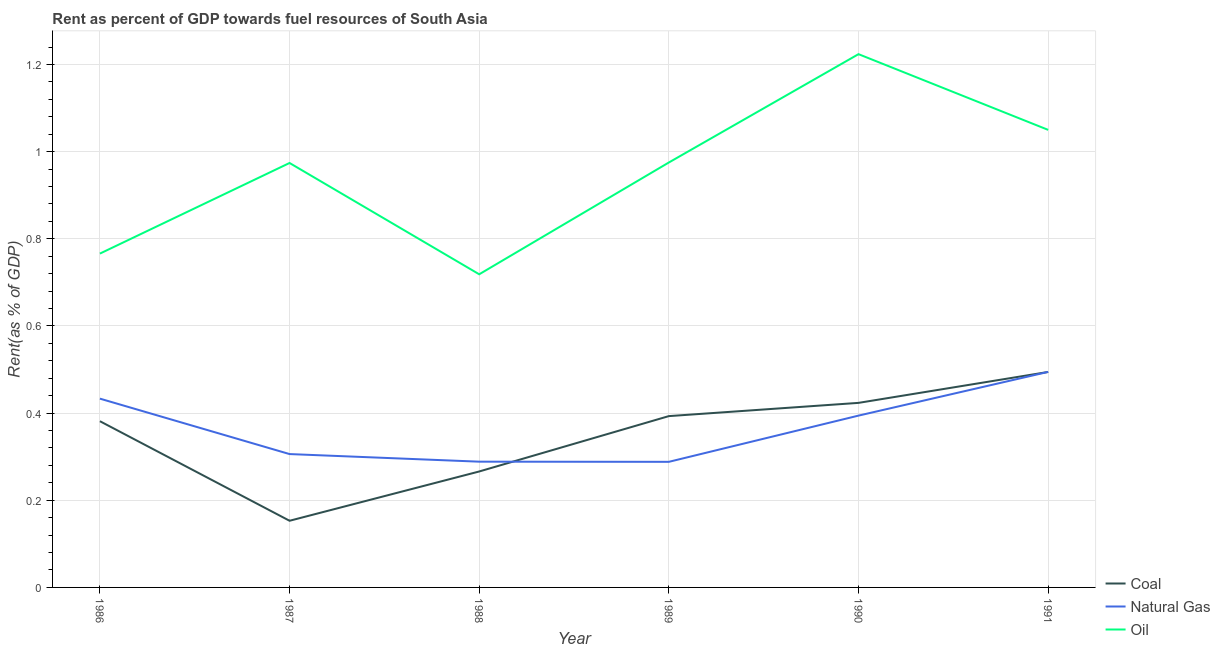Does the line corresponding to rent towards coal intersect with the line corresponding to rent towards oil?
Ensure brevity in your answer.  No. What is the rent towards natural gas in 1991?
Offer a very short reply. 0.49. Across all years, what is the maximum rent towards natural gas?
Provide a succinct answer. 0.49. Across all years, what is the minimum rent towards coal?
Your response must be concise. 0.15. In which year was the rent towards coal maximum?
Offer a very short reply. 1991. In which year was the rent towards oil minimum?
Give a very brief answer. 1988. What is the total rent towards oil in the graph?
Keep it short and to the point. 5.71. What is the difference between the rent towards natural gas in 1986 and that in 1987?
Your answer should be compact. 0.13. What is the difference between the rent towards coal in 1986 and the rent towards oil in 1990?
Give a very brief answer. -0.84. What is the average rent towards natural gas per year?
Your answer should be compact. 0.37. In the year 1989, what is the difference between the rent towards natural gas and rent towards coal?
Provide a short and direct response. -0.1. What is the ratio of the rent towards coal in 1987 to that in 1990?
Your response must be concise. 0.36. Is the difference between the rent towards natural gas in 1986 and 1989 greater than the difference between the rent towards oil in 1986 and 1989?
Your answer should be compact. Yes. What is the difference between the highest and the second highest rent towards natural gas?
Ensure brevity in your answer.  0.06. What is the difference between the highest and the lowest rent towards oil?
Offer a terse response. 0.51. Does the rent towards oil monotonically increase over the years?
Your answer should be very brief. No. Is the rent towards coal strictly less than the rent towards oil over the years?
Provide a short and direct response. Yes. How many lines are there?
Your response must be concise. 3. What is the difference between two consecutive major ticks on the Y-axis?
Offer a terse response. 0.2. How many legend labels are there?
Make the answer very short. 3. How are the legend labels stacked?
Give a very brief answer. Vertical. What is the title of the graph?
Provide a short and direct response. Rent as percent of GDP towards fuel resources of South Asia. What is the label or title of the X-axis?
Keep it short and to the point. Year. What is the label or title of the Y-axis?
Keep it short and to the point. Rent(as % of GDP). What is the Rent(as % of GDP) in Coal in 1986?
Provide a succinct answer. 0.38. What is the Rent(as % of GDP) of Natural Gas in 1986?
Your answer should be very brief. 0.43. What is the Rent(as % of GDP) of Oil in 1986?
Your response must be concise. 0.77. What is the Rent(as % of GDP) in Coal in 1987?
Offer a very short reply. 0.15. What is the Rent(as % of GDP) of Natural Gas in 1987?
Provide a short and direct response. 0.31. What is the Rent(as % of GDP) in Oil in 1987?
Give a very brief answer. 0.97. What is the Rent(as % of GDP) of Coal in 1988?
Offer a very short reply. 0.27. What is the Rent(as % of GDP) of Natural Gas in 1988?
Make the answer very short. 0.29. What is the Rent(as % of GDP) of Oil in 1988?
Ensure brevity in your answer.  0.72. What is the Rent(as % of GDP) in Coal in 1989?
Offer a very short reply. 0.39. What is the Rent(as % of GDP) in Natural Gas in 1989?
Ensure brevity in your answer.  0.29. What is the Rent(as % of GDP) of Oil in 1989?
Ensure brevity in your answer.  0.98. What is the Rent(as % of GDP) of Coal in 1990?
Make the answer very short. 0.42. What is the Rent(as % of GDP) in Natural Gas in 1990?
Your answer should be very brief. 0.39. What is the Rent(as % of GDP) in Oil in 1990?
Ensure brevity in your answer.  1.22. What is the Rent(as % of GDP) in Coal in 1991?
Offer a very short reply. 0.49. What is the Rent(as % of GDP) in Natural Gas in 1991?
Your answer should be very brief. 0.49. What is the Rent(as % of GDP) in Oil in 1991?
Your response must be concise. 1.05. Across all years, what is the maximum Rent(as % of GDP) in Coal?
Your answer should be compact. 0.49. Across all years, what is the maximum Rent(as % of GDP) of Natural Gas?
Your answer should be very brief. 0.49. Across all years, what is the maximum Rent(as % of GDP) in Oil?
Give a very brief answer. 1.22. Across all years, what is the minimum Rent(as % of GDP) in Coal?
Offer a very short reply. 0.15. Across all years, what is the minimum Rent(as % of GDP) of Natural Gas?
Give a very brief answer. 0.29. Across all years, what is the minimum Rent(as % of GDP) in Oil?
Keep it short and to the point. 0.72. What is the total Rent(as % of GDP) of Coal in the graph?
Ensure brevity in your answer.  2.11. What is the total Rent(as % of GDP) in Natural Gas in the graph?
Your response must be concise. 2.21. What is the total Rent(as % of GDP) of Oil in the graph?
Make the answer very short. 5.71. What is the difference between the Rent(as % of GDP) of Coal in 1986 and that in 1987?
Your answer should be very brief. 0.23. What is the difference between the Rent(as % of GDP) in Natural Gas in 1986 and that in 1987?
Offer a very short reply. 0.13. What is the difference between the Rent(as % of GDP) in Oil in 1986 and that in 1987?
Keep it short and to the point. -0.21. What is the difference between the Rent(as % of GDP) in Coal in 1986 and that in 1988?
Ensure brevity in your answer.  0.12. What is the difference between the Rent(as % of GDP) of Natural Gas in 1986 and that in 1988?
Provide a short and direct response. 0.14. What is the difference between the Rent(as % of GDP) in Oil in 1986 and that in 1988?
Provide a short and direct response. 0.05. What is the difference between the Rent(as % of GDP) of Coal in 1986 and that in 1989?
Your response must be concise. -0.01. What is the difference between the Rent(as % of GDP) in Natural Gas in 1986 and that in 1989?
Offer a very short reply. 0.15. What is the difference between the Rent(as % of GDP) of Oil in 1986 and that in 1989?
Offer a very short reply. -0.21. What is the difference between the Rent(as % of GDP) of Coal in 1986 and that in 1990?
Provide a succinct answer. -0.04. What is the difference between the Rent(as % of GDP) in Natural Gas in 1986 and that in 1990?
Offer a very short reply. 0.04. What is the difference between the Rent(as % of GDP) of Oil in 1986 and that in 1990?
Your answer should be compact. -0.46. What is the difference between the Rent(as % of GDP) of Coal in 1986 and that in 1991?
Provide a succinct answer. -0.11. What is the difference between the Rent(as % of GDP) of Natural Gas in 1986 and that in 1991?
Offer a very short reply. -0.06. What is the difference between the Rent(as % of GDP) of Oil in 1986 and that in 1991?
Your answer should be compact. -0.28. What is the difference between the Rent(as % of GDP) of Coal in 1987 and that in 1988?
Your answer should be very brief. -0.11. What is the difference between the Rent(as % of GDP) of Natural Gas in 1987 and that in 1988?
Give a very brief answer. 0.02. What is the difference between the Rent(as % of GDP) in Oil in 1987 and that in 1988?
Provide a succinct answer. 0.26. What is the difference between the Rent(as % of GDP) of Coal in 1987 and that in 1989?
Ensure brevity in your answer.  -0.24. What is the difference between the Rent(as % of GDP) in Natural Gas in 1987 and that in 1989?
Your response must be concise. 0.02. What is the difference between the Rent(as % of GDP) in Oil in 1987 and that in 1989?
Make the answer very short. -0. What is the difference between the Rent(as % of GDP) in Coal in 1987 and that in 1990?
Keep it short and to the point. -0.27. What is the difference between the Rent(as % of GDP) in Natural Gas in 1987 and that in 1990?
Keep it short and to the point. -0.09. What is the difference between the Rent(as % of GDP) in Oil in 1987 and that in 1990?
Provide a succinct answer. -0.25. What is the difference between the Rent(as % of GDP) in Coal in 1987 and that in 1991?
Your answer should be very brief. -0.34. What is the difference between the Rent(as % of GDP) in Natural Gas in 1987 and that in 1991?
Provide a succinct answer. -0.19. What is the difference between the Rent(as % of GDP) of Oil in 1987 and that in 1991?
Your answer should be very brief. -0.08. What is the difference between the Rent(as % of GDP) of Coal in 1988 and that in 1989?
Offer a terse response. -0.13. What is the difference between the Rent(as % of GDP) in Natural Gas in 1988 and that in 1989?
Provide a short and direct response. 0. What is the difference between the Rent(as % of GDP) in Oil in 1988 and that in 1989?
Provide a short and direct response. -0.26. What is the difference between the Rent(as % of GDP) in Coal in 1988 and that in 1990?
Offer a terse response. -0.16. What is the difference between the Rent(as % of GDP) in Natural Gas in 1988 and that in 1990?
Offer a very short reply. -0.11. What is the difference between the Rent(as % of GDP) of Oil in 1988 and that in 1990?
Give a very brief answer. -0.51. What is the difference between the Rent(as % of GDP) in Coal in 1988 and that in 1991?
Keep it short and to the point. -0.23. What is the difference between the Rent(as % of GDP) of Natural Gas in 1988 and that in 1991?
Offer a terse response. -0.21. What is the difference between the Rent(as % of GDP) of Oil in 1988 and that in 1991?
Offer a very short reply. -0.33. What is the difference between the Rent(as % of GDP) in Coal in 1989 and that in 1990?
Your answer should be compact. -0.03. What is the difference between the Rent(as % of GDP) of Natural Gas in 1989 and that in 1990?
Make the answer very short. -0.11. What is the difference between the Rent(as % of GDP) of Oil in 1989 and that in 1990?
Provide a succinct answer. -0.25. What is the difference between the Rent(as % of GDP) of Coal in 1989 and that in 1991?
Provide a short and direct response. -0.1. What is the difference between the Rent(as % of GDP) in Natural Gas in 1989 and that in 1991?
Provide a succinct answer. -0.21. What is the difference between the Rent(as % of GDP) in Oil in 1989 and that in 1991?
Give a very brief answer. -0.07. What is the difference between the Rent(as % of GDP) of Coal in 1990 and that in 1991?
Keep it short and to the point. -0.07. What is the difference between the Rent(as % of GDP) in Natural Gas in 1990 and that in 1991?
Keep it short and to the point. -0.1. What is the difference between the Rent(as % of GDP) of Oil in 1990 and that in 1991?
Your answer should be compact. 0.17. What is the difference between the Rent(as % of GDP) of Coal in 1986 and the Rent(as % of GDP) of Natural Gas in 1987?
Offer a very short reply. 0.08. What is the difference between the Rent(as % of GDP) of Coal in 1986 and the Rent(as % of GDP) of Oil in 1987?
Provide a short and direct response. -0.59. What is the difference between the Rent(as % of GDP) of Natural Gas in 1986 and the Rent(as % of GDP) of Oil in 1987?
Provide a succinct answer. -0.54. What is the difference between the Rent(as % of GDP) of Coal in 1986 and the Rent(as % of GDP) of Natural Gas in 1988?
Offer a terse response. 0.09. What is the difference between the Rent(as % of GDP) in Coal in 1986 and the Rent(as % of GDP) in Oil in 1988?
Ensure brevity in your answer.  -0.34. What is the difference between the Rent(as % of GDP) in Natural Gas in 1986 and the Rent(as % of GDP) in Oil in 1988?
Offer a terse response. -0.29. What is the difference between the Rent(as % of GDP) in Coal in 1986 and the Rent(as % of GDP) in Natural Gas in 1989?
Provide a succinct answer. 0.09. What is the difference between the Rent(as % of GDP) in Coal in 1986 and the Rent(as % of GDP) in Oil in 1989?
Give a very brief answer. -0.59. What is the difference between the Rent(as % of GDP) in Natural Gas in 1986 and the Rent(as % of GDP) in Oil in 1989?
Your answer should be compact. -0.54. What is the difference between the Rent(as % of GDP) of Coal in 1986 and the Rent(as % of GDP) of Natural Gas in 1990?
Your response must be concise. -0.01. What is the difference between the Rent(as % of GDP) of Coal in 1986 and the Rent(as % of GDP) of Oil in 1990?
Your answer should be compact. -0.84. What is the difference between the Rent(as % of GDP) in Natural Gas in 1986 and the Rent(as % of GDP) in Oil in 1990?
Ensure brevity in your answer.  -0.79. What is the difference between the Rent(as % of GDP) in Coal in 1986 and the Rent(as % of GDP) in Natural Gas in 1991?
Your answer should be compact. -0.11. What is the difference between the Rent(as % of GDP) of Coal in 1986 and the Rent(as % of GDP) of Oil in 1991?
Make the answer very short. -0.67. What is the difference between the Rent(as % of GDP) of Natural Gas in 1986 and the Rent(as % of GDP) of Oil in 1991?
Ensure brevity in your answer.  -0.62. What is the difference between the Rent(as % of GDP) in Coal in 1987 and the Rent(as % of GDP) in Natural Gas in 1988?
Provide a succinct answer. -0.14. What is the difference between the Rent(as % of GDP) of Coal in 1987 and the Rent(as % of GDP) of Oil in 1988?
Your response must be concise. -0.57. What is the difference between the Rent(as % of GDP) of Natural Gas in 1987 and the Rent(as % of GDP) of Oil in 1988?
Provide a succinct answer. -0.41. What is the difference between the Rent(as % of GDP) of Coal in 1987 and the Rent(as % of GDP) of Natural Gas in 1989?
Give a very brief answer. -0.14. What is the difference between the Rent(as % of GDP) in Coal in 1987 and the Rent(as % of GDP) in Oil in 1989?
Your answer should be very brief. -0.82. What is the difference between the Rent(as % of GDP) of Natural Gas in 1987 and the Rent(as % of GDP) of Oil in 1989?
Offer a terse response. -0.67. What is the difference between the Rent(as % of GDP) in Coal in 1987 and the Rent(as % of GDP) in Natural Gas in 1990?
Your answer should be very brief. -0.24. What is the difference between the Rent(as % of GDP) of Coal in 1987 and the Rent(as % of GDP) of Oil in 1990?
Your answer should be very brief. -1.07. What is the difference between the Rent(as % of GDP) in Natural Gas in 1987 and the Rent(as % of GDP) in Oil in 1990?
Ensure brevity in your answer.  -0.92. What is the difference between the Rent(as % of GDP) of Coal in 1987 and the Rent(as % of GDP) of Natural Gas in 1991?
Provide a short and direct response. -0.34. What is the difference between the Rent(as % of GDP) in Coal in 1987 and the Rent(as % of GDP) in Oil in 1991?
Provide a short and direct response. -0.9. What is the difference between the Rent(as % of GDP) of Natural Gas in 1987 and the Rent(as % of GDP) of Oil in 1991?
Keep it short and to the point. -0.74. What is the difference between the Rent(as % of GDP) in Coal in 1988 and the Rent(as % of GDP) in Natural Gas in 1989?
Provide a short and direct response. -0.02. What is the difference between the Rent(as % of GDP) in Coal in 1988 and the Rent(as % of GDP) in Oil in 1989?
Provide a succinct answer. -0.71. What is the difference between the Rent(as % of GDP) in Natural Gas in 1988 and the Rent(as % of GDP) in Oil in 1989?
Offer a terse response. -0.69. What is the difference between the Rent(as % of GDP) in Coal in 1988 and the Rent(as % of GDP) in Natural Gas in 1990?
Make the answer very short. -0.13. What is the difference between the Rent(as % of GDP) of Coal in 1988 and the Rent(as % of GDP) of Oil in 1990?
Provide a succinct answer. -0.96. What is the difference between the Rent(as % of GDP) of Natural Gas in 1988 and the Rent(as % of GDP) of Oil in 1990?
Ensure brevity in your answer.  -0.94. What is the difference between the Rent(as % of GDP) in Coal in 1988 and the Rent(as % of GDP) in Natural Gas in 1991?
Offer a very short reply. -0.23. What is the difference between the Rent(as % of GDP) of Coal in 1988 and the Rent(as % of GDP) of Oil in 1991?
Keep it short and to the point. -0.78. What is the difference between the Rent(as % of GDP) in Natural Gas in 1988 and the Rent(as % of GDP) in Oil in 1991?
Ensure brevity in your answer.  -0.76. What is the difference between the Rent(as % of GDP) of Coal in 1989 and the Rent(as % of GDP) of Natural Gas in 1990?
Provide a short and direct response. -0. What is the difference between the Rent(as % of GDP) of Coal in 1989 and the Rent(as % of GDP) of Oil in 1990?
Ensure brevity in your answer.  -0.83. What is the difference between the Rent(as % of GDP) in Natural Gas in 1989 and the Rent(as % of GDP) in Oil in 1990?
Provide a succinct answer. -0.94. What is the difference between the Rent(as % of GDP) of Coal in 1989 and the Rent(as % of GDP) of Natural Gas in 1991?
Offer a terse response. -0.1. What is the difference between the Rent(as % of GDP) of Coal in 1989 and the Rent(as % of GDP) of Oil in 1991?
Provide a succinct answer. -0.66. What is the difference between the Rent(as % of GDP) of Natural Gas in 1989 and the Rent(as % of GDP) of Oil in 1991?
Provide a short and direct response. -0.76. What is the difference between the Rent(as % of GDP) of Coal in 1990 and the Rent(as % of GDP) of Natural Gas in 1991?
Your answer should be compact. -0.07. What is the difference between the Rent(as % of GDP) in Coal in 1990 and the Rent(as % of GDP) in Oil in 1991?
Your answer should be very brief. -0.63. What is the difference between the Rent(as % of GDP) in Natural Gas in 1990 and the Rent(as % of GDP) in Oil in 1991?
Provide a short and direct response. -0.66. What is the average Rent(as % of GDP) in Coal per year?
Keep it short and to the point. 0.35. What is the average Rent(as % of GDP) in Natural Gas per year?
Ensure brevity in your answer.  0.37. What is the average Rent(as % of GDP) in Oil per year?
Keep it short and to the point. 0.95. In the year 1986, what is the difference between the Rent(as % of GDP) in Coal and Rent(as % of GDP) in Natural Gas?
Offer a terse response. -0.05. In the year 1986, what is the difference between the Rent(as % of GDP) of Coal and Rent(as % of GDP) of Oil?
Your answer should be very brief. -0.38. In the year 1986, what is the difference between the Rent(as % of GDP) of Natural Gas and Rent(as % of GDP) of Oil?
Your response must be concise. -0.33. In the year 1987, what is the difference between the Rent(as % of GDP) in Coal and Rent(as % of GDP) in Natural Gas?
Your answer should be very brief. -0.15. In the year 1987, what is the difference between the Rent(as % of GDP) in Coal and Rent(as % of GDP) in Oil?
Make the answer very short. -0.82. In the year 1987, what is the difference between the Rent(as % of GDP) in Natural Gas and Rent(as % of GDP) in Oil?
Offer a very short reply. -0.67. In the year 1988, what is the difference between the Rent(as % of GDP) in Coal and Rent(as % of GDP) in Natural Gas?
Provide a short and direct response. -0.02. In the year 1988, what is the difference between the Rent(as % of GDP) in Coal and Rent(as % of GDP) in Oil?
Your answer should be very brief. -0.45. In the year 1988, what is the difference between the Rent(as % of GDP) of Natural Gas and Rent(as % of GDP) of Oil?
Make the answer very short. -0.43. In the year 1989, what is the difference between the Rent(as % of GDP) of Coal and Rent(as % of GDP) of Natural Gas?
Give a very brief answer. 0.1. In the year 1989, what is the difference between the Rent(as % of GDP) of Coal and Rent(as % of GDP) of Oil?
Offer a very short reply. -0.58. In the year 1989, what is the difference between the Rent(as % of GDP) of Natural Gas and Rent(as % of GDP) of Oil?
Provide a short and direct response. -0.69. In the year 1990, what is the difference between the Rent(as % of GDP) in Coal and Rent(as % of GDP) in Natural Gas?
Offer a terse response. 0.03. In the year 1990, what is the difference between the Rent(as % of GDP) of Coal and Rent(as % of GDP) of Oil?
Offer a terse response. -0.8. In the year 1990, what is the difference between the Rent(as % of GDP) in Natural Gas and Rent(as % of GDP) in Oil?
Provide a short and direct response. -0.83. In the year 1991, what is the difference between the Rent(as % of GDP) of Coal and Rent(as % of GDP) of Natural Gas?
Ensure brevity in your answer.  -0. In the year 1991, what is the difference between the Rent(as % of GDP) in Coal and Rent(as % of GDP) in Oil?
Offer a very short reply. -0.56. In the year 1991, what is the difference between the Rent(as % of GDP) in Natural Gas and Rent(as % of GDP) in Oil?
Your answer should be compact. -0.56. What is the ratio of the Rent(as % of GDP) in Coal in 1986 to that in 1987?
Make the answer very short. 2.49. What is the ratio of the Rent(as % of GDP) in Natural Gas in 1986 to that in 1987?
Offer a very short reply. 1.42. What is the ratio of the Rent(as % of GDP) of Oil in 1986 to that in 1987?
Offer a terse response. 0.79. What is the ratio of the Rent(as % of GDP) in Coal in 1986 to that in 1988?
Make the answer very short. 1.43. What is the ratio of the Rent(as % of GDP) in Natural Gas in 1986 to that in 1988?
Give a very brief answer. 1.5. What is the ratio of the Rent(as % of GDP) of Oil in 1986 to that in 1988?
Your answer should be compact. 1.07. What is the ratio of the Rent(as % of GDP) of Coal in 1986 to that in 1989?
Your answer should be compact. 0.97. What is the ratio of the Rent(as % of GDP) in Natural Gas in 1986 to that in 1989?
Give a very brief answer. 1.5. What is the ratio of the Rent(as % of GDP) of Oil in 1986 to that in 1989?
Ensure brevity in your answer.  0.79. What is the ratio of the Rent(as % of GDP) of Coal in 1986 to that in 1990?
Make the answer very short. 0.9. What is the ratio of the Rent(as % of GDP) in Natural Gas in 1986 to that in 1990?
Ensure brevity in your answer.  1.1. What is the ratio of the Rent(as % of GDP) of Oil in 1986 to that in 1990?
Give a very brief answer. 0.63. What is the ratio of the Rent(as % of GDP) of Coal in 1986 to that in 1991?
Provide a succinct answer. 0.77. What is the ratio of the Rent(as % of GDP) of Natural Gas in 1986 to that in 1991?
Provide a succinct answer. 0.88. What is the ratio of the Rent(as % of GDP) in Oil in 1986 to that in 1991?
Offer a very short reply. 0.73. What is the ratio of the Rent(as % of GDP) of Coal in 1987 to that in 1988?
Provide a succinct answer. 0.57. What is the ratio of the Rent(as % of GDP) in Natural Gas in 1987 to that in 1988?
Offer a very short reply. 1.06. What is the ratio of the Rent(as % of GDP) of Oil in 1987 to that in 1988?
Ensure brevity in your answer.  1.36. What is the ratio of the Rent(as % of GDP) of Coal in 1987 to that in 1989?
Give a very brief answer. 0.39. What is the ratio of the Rent(as % of GDP) of Natural Gas in 1987 to that in 1989?
Provide a short and direct response. 1.06. What is the ratio of the Rent(as % of GDP) of Coal in 1987 to that in 1990?
Your answer should be compact. 0.36. What is the ratio of the Rent(as % of GDP) of Natural Gas in 1987 to that in 1990?
Keep it short and to the point. 0.78. What is the ratio of the Rent(as % of GDP) of Oil in 1987 to that in 1990?
Offer a terse response. 0.8. What is the ratio of the Rent(as % of GDP) of Coal in 1987 to that in 1991?
Offer a terse response. 0.31. What is the ratio of the Rent(as % of GDP) in Natural Gas in 1987 to that in 1991?
Provide a succinct answer. 0.62. What is the ratio of the Rent(as % of GDP) in Oil in 1987 to that in 1991?
Give a very brief answer. 0.93. What is the ratio of the Rent(as % of GDP) of Coal in 1988 to that in 1989?
Ensure brevity in your answer.  0.68. What is the ratio of the Rent(as % of GDP) in Natural Gas in 1988 to that in 1989?
Your answer should be very brief. 1. What is the ratio of the Rent(as % of GDP) of Oil in 1988 to that in 1989?
Make the answer very short. 0.74. What is the ratio of the Rent(as % of GDP) in Coal in 1988 to that in 1990?
Make the answer very short. 0.63. What is the ratio of the Rent(as % of GDP) of Natural Gas in 1988 to that in 1990?
Make the answer very short. 0.73. What is the ratio of the Rent(as % of GDP) of Oil in 1988 to that in 1990?
Your answer should be compact. 0.59. What is the ratio of the Rent(as % of GDP) of Coal in 1988 to that in 1991?
Keep it short and to the point. 0.54. What is the ratio of the Rent(as % of GDP) in Natural Gas in 1988 to that in 1991?
Your answer should be very brief. 0.58. What is the ratio of the Rent(as % of GDP) of Oil in 1988 to that in 1991?
Your response must be concise. 0.68. What is the ratio of the Rent(as % of GDP) in Coal in 1989 to that in 1990?
Make the answer very short. 0.93. What is the ratio of the Rent(as % of GDP) in Natural Gas in 1989 to that in 1990?
Offer a very short reply. 0.73. What is the ratio of the Rent(as % of GDP) in Oil in 1989 to that in 1990?
Give a very brief answer. 0.8. What is the ratio of the Rent(as % of GDP) of Coal in 1989 to that in 1991?
Ensure brevity in your answer.  0.8. What is the ratio of the Rent(as % of GDP) in Natural Gas in 1989 to that in 1991?
Offer a very short reply. 0.58. What is the ratio of the Rent(as % of GDP) in Oil in 1989 to that in 1991?
Give a very brief answer. 0.93. What is the ratio of the Rent(as % of GDP) in Coal in 1990 to that in 1991?
Provide a succinct answer. 0.86. What is the ratio of the Rent(as % of GDP) of Natural Gas in 1990 to that in 1991?
Provide a succinct answer. 0.8. What is the ratio of the Rent(as % of GDP) in Oil in 1990 to that in 1991?
Offer a very short reply. 1.17. What is the difference between the highest and the second highest Rent(as % of GDP) in Coal?
Provide a succinct answer. 0.07. What is the difference between the highest and the second highest Rent(as % of GDP) of Natural Gas?
Provide a succinct answer. 0.06. What is the difference between the highest and the second highest Rent(as % of GDP) in Oil?
Your answer should be very brief. 0.17. What is the difference between the highest and the lowest Rent(as % of GDP) of Coal?
Keep it short and to the point. 0.34. What is the difference between the highest and the lowest Rent(as % of GDP) in Natural Gas?
Your answer should be compact. 0.21. What is the difference between the highest and the lowest Rent(as % of GDP) in Oil?
Provide a succinct answer. 0.51. 